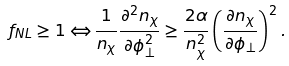<formula> <loc_0><loc_0><loc_500><loc_500>f _ { N L } \geq 1 \Leftrightarrow \frac { 1 } { n _ { \chi } } \frac { \partial ^ { 2 } n _ { \chi } } { \partial \phi _ { \perp } ^ { 2 } } \geq \frac { 2 \alpha } { n _ { \chi } ^ { 2 } } \left ( \frac { \partial n _ { \chi } } { \partial \phi _ { \perp } } \right ) ^ { 2 } .</formula> 